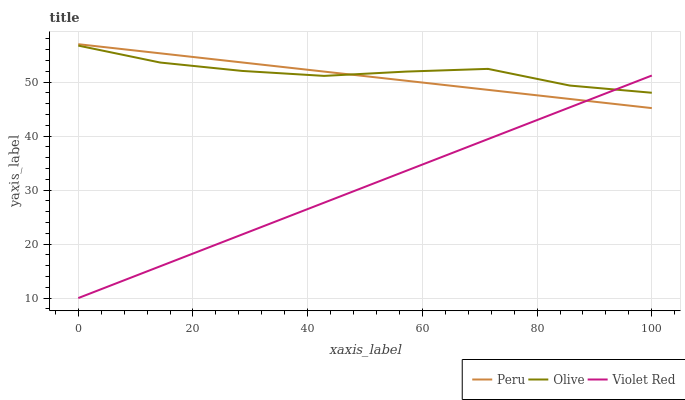Does Violet Red have the minimum area under the curve?
Answer yes or no. Yes. Does Olive have the maximum area under the curve?
Answer yes or no. Yes. Does Peru have the minimum area under the curve?
Answer yes or no. No. Does Peru have the maximum area under the curve?
Answer yes or no. No. Is Violet Red the smoothest?
Answer yes or no. Yes. Is Olive the roughest?
Answer yes or no. Yes. Is Peru the smoothest?
Answer yes or no. No. Is Peru the roughest?
Answer yes or no. No. Does Violet Red have the lowest value?
Answer yes or no. Yes. Does Peru have the lowest value?
Answer yes or no. No. Does Peru have the highest value?
Answer yes or no. Yes. Does Violet Red have the highest value?
Answer yes or no. No. Does Olive intersect Violet Red?
Answer yes or no. Yes. Is Olive less than Violet Red?
Answer yes or no. No. Is Olive greater than Violet Red?
Answer yes or no. No. 